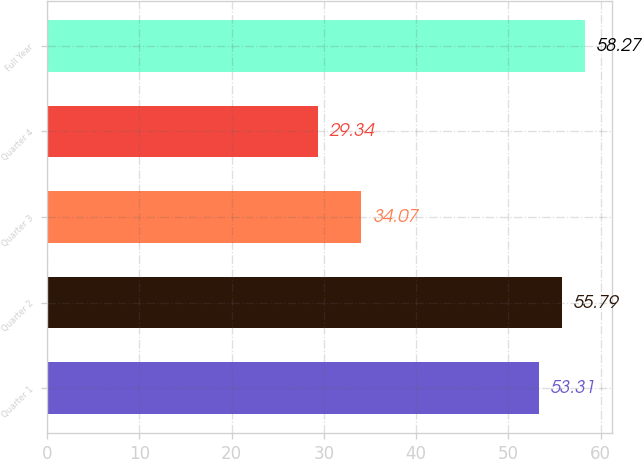Convert chart. <chart><loc_0><loc_0><loc_500><loc_500><bar_chart><fcel>Quarter 1<fcel>Quarter 2<fcel>Quarter 3<fcel>Quarter 4<fcel>Full Year<nl><fcel>53.31<fcel>55.79<fcel>34.07<fcel>29.34<fcel>58.27<nl></chart> 